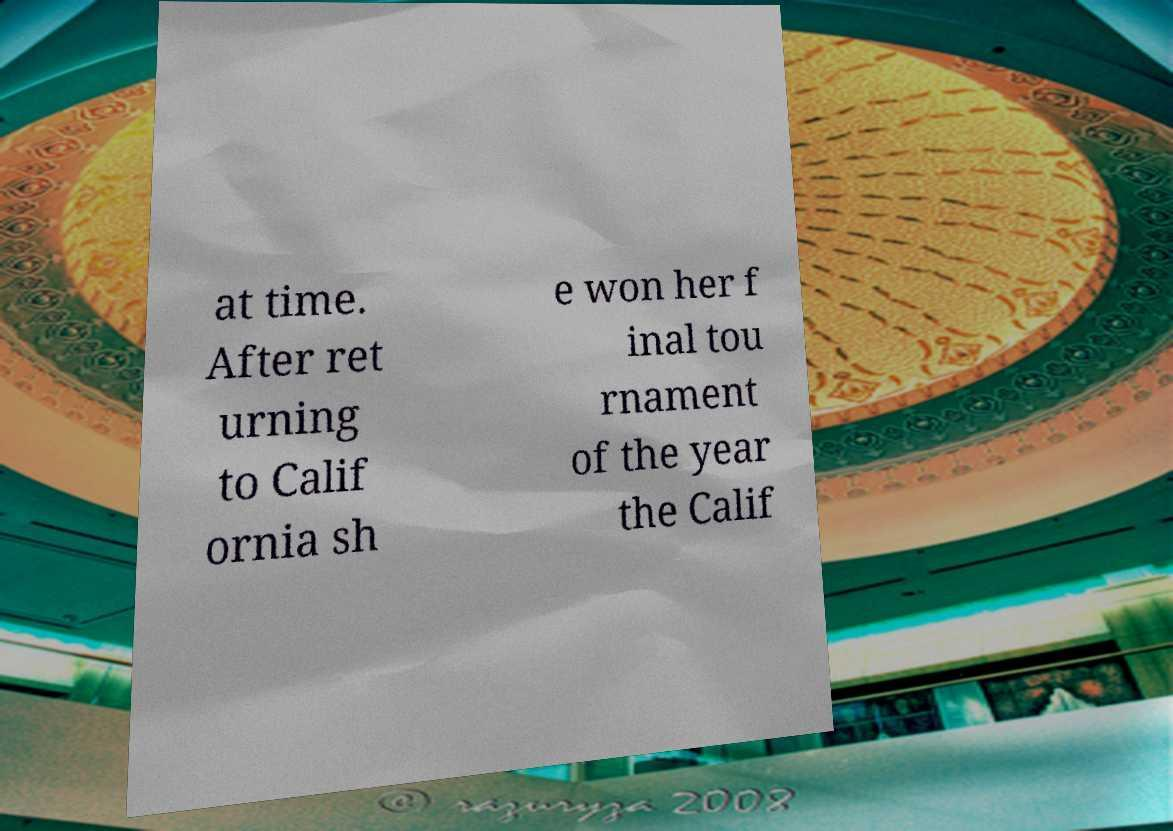Please read and relay the text visible in this image. What does it say? at time. After ret urning to Calif ornia sh e won her f inal tou rnament of the year the Calif 